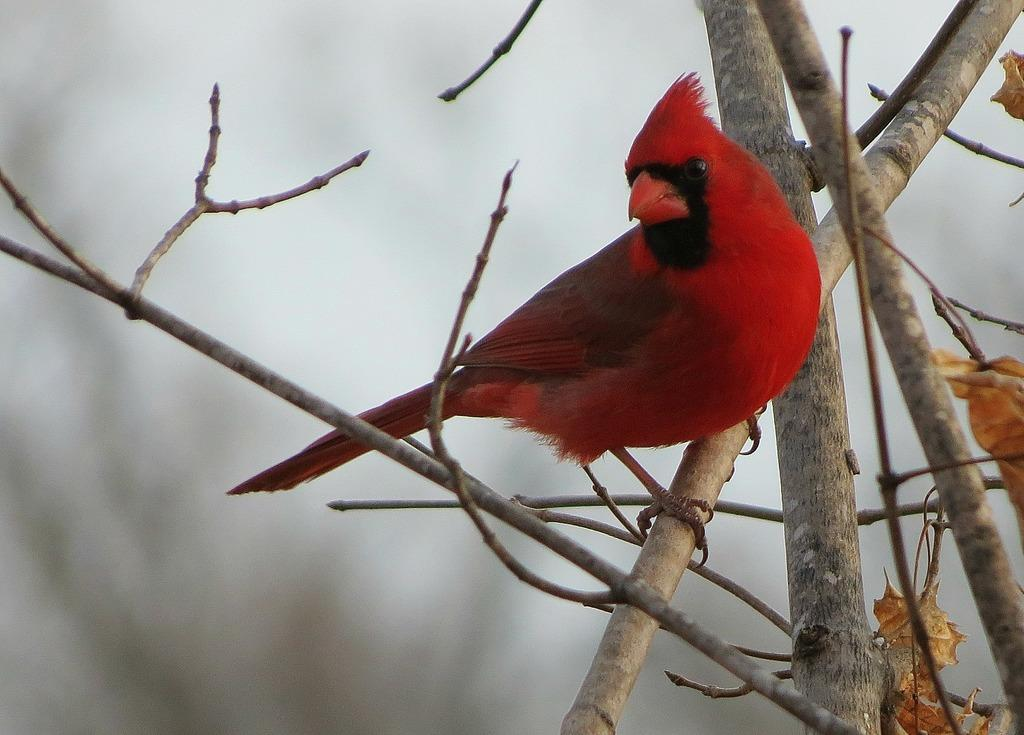What type of bird can be seen in the image? There is a red color bird in the image. Where is the bird located? The bird is on the branch of a tree. Can you describe the background of the image? The background of the image is blurred. How many brothers does the bird have in the image? There is no information about the bird's brothers in the image. What type of stage is the bird performing on in the image? There is no stage present in the image; the bird is on the branch of a tree. 